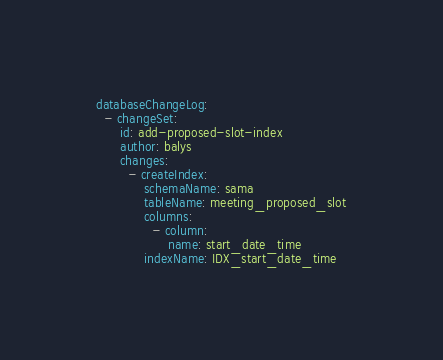<code> <loc_0><loc_0><loc_500><loc_500><_YAML_>databaseChangeLog:
  - changeSet:
      id: add-proposed-slot-index
      author: balys
      changes:
        - createIndex:
            schemaName: sama
            tableName: meeting_proposed_slot
            columns:
              - column:
                  name: start_date_time
            indexName: IDX_start_date_time
</code> 